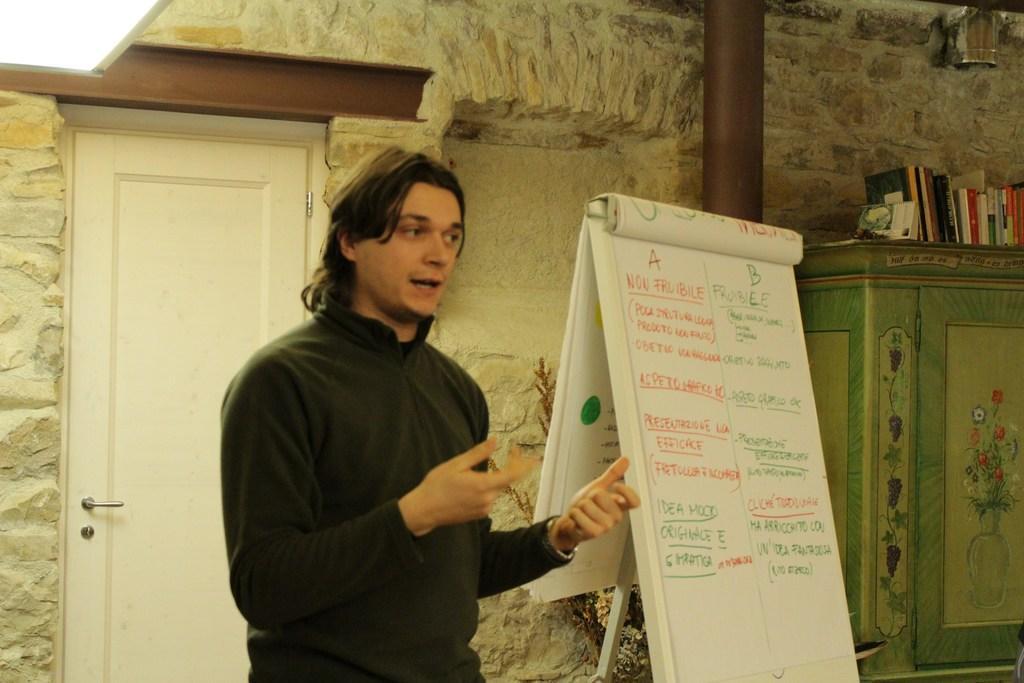Could you give a brief overview of what you see in this image? In this image I can see a person and a board. In the background I can see a cupboard on which books are there, wall, pillar and a door. This image is taken in a room. 